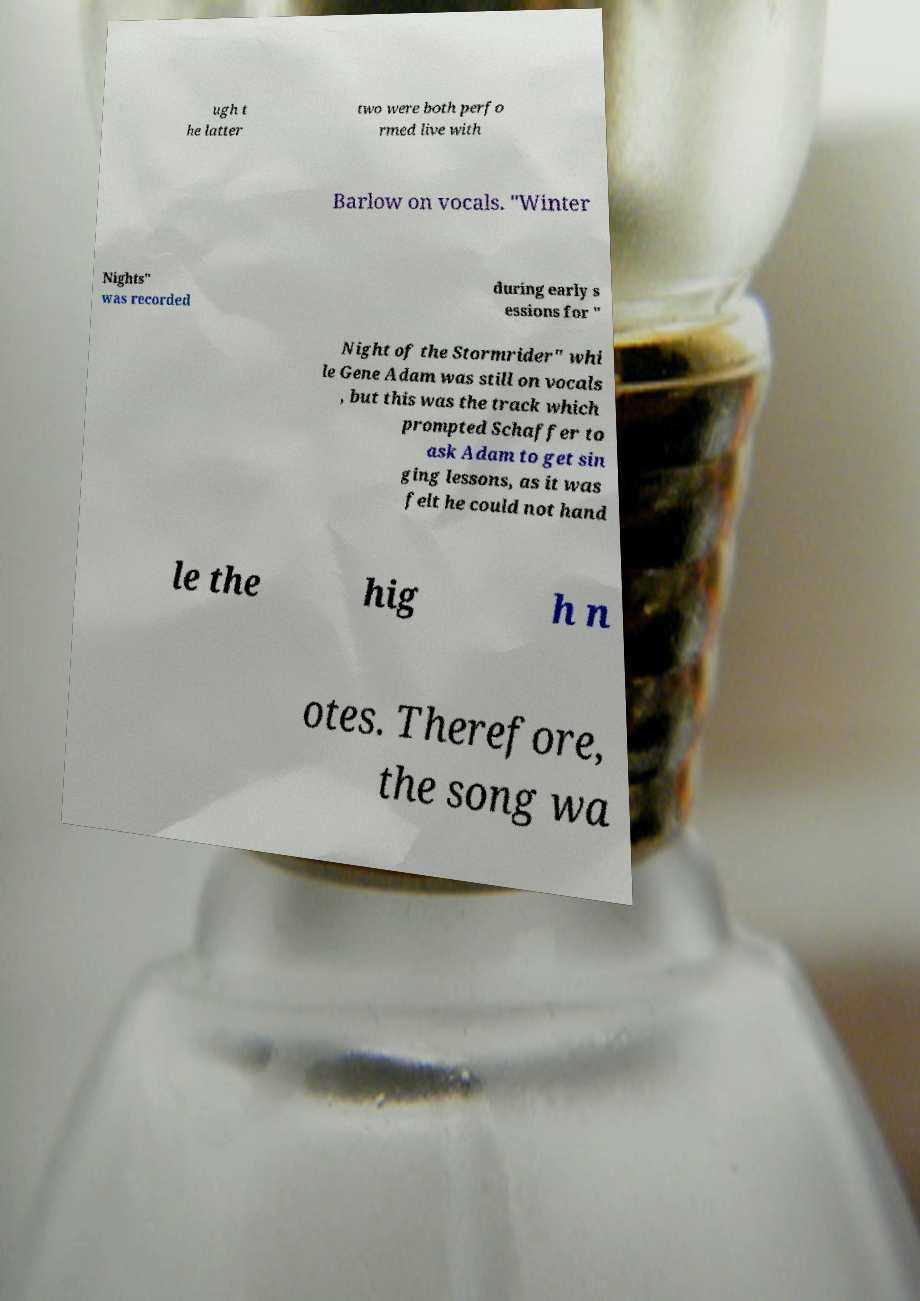Can you accurately transcribe the text from the provided image for me? ugh t he latter two were both perfo rmed live with Barlow on vocals. "Winter Nights" was recorded during early s essions for " Night of the Stormrider" whi le Gene Adam was still on vocals , but this was the track which prompted Schaffer to ask Adam to get sin ging lessons, as it was felt he could not hand le the hig h n otes. Therefore, the song wa 